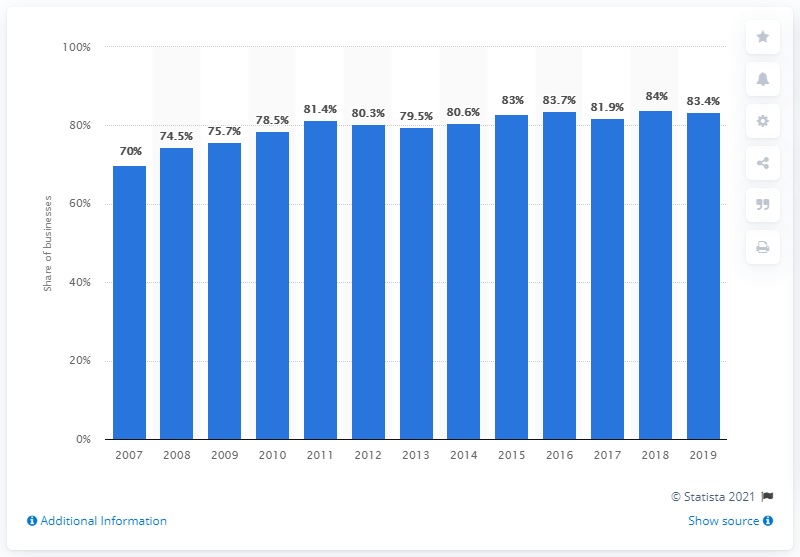Mention a couple of crucial points in this snapshot. In 2019, 83.4% of businesses with ten or more employees had a website, according to statistics. 